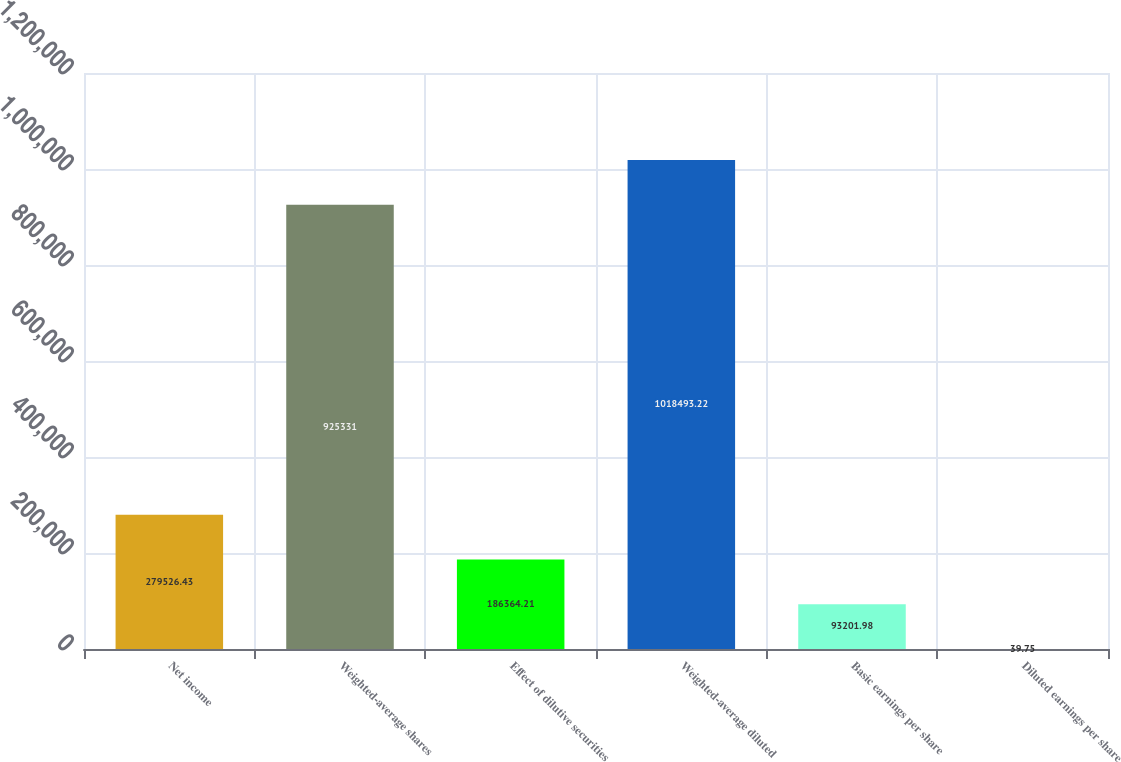Convert chart. <chart><loc_0><loc_0><loc_500><loc_500><bar_chart><fcel>Net income<fcel>Weighted-average shares<fcel>Effect of dilutive securities<fcel>Weighted-average diluted<fcel>Basic earnings per share<fcel>Diluted earnings per share<nl><fcel>279526<fcel>925331<fcel>186364<fcel>1.01849e+06<fcel>93202<fcel>39.75<nl></chart> 